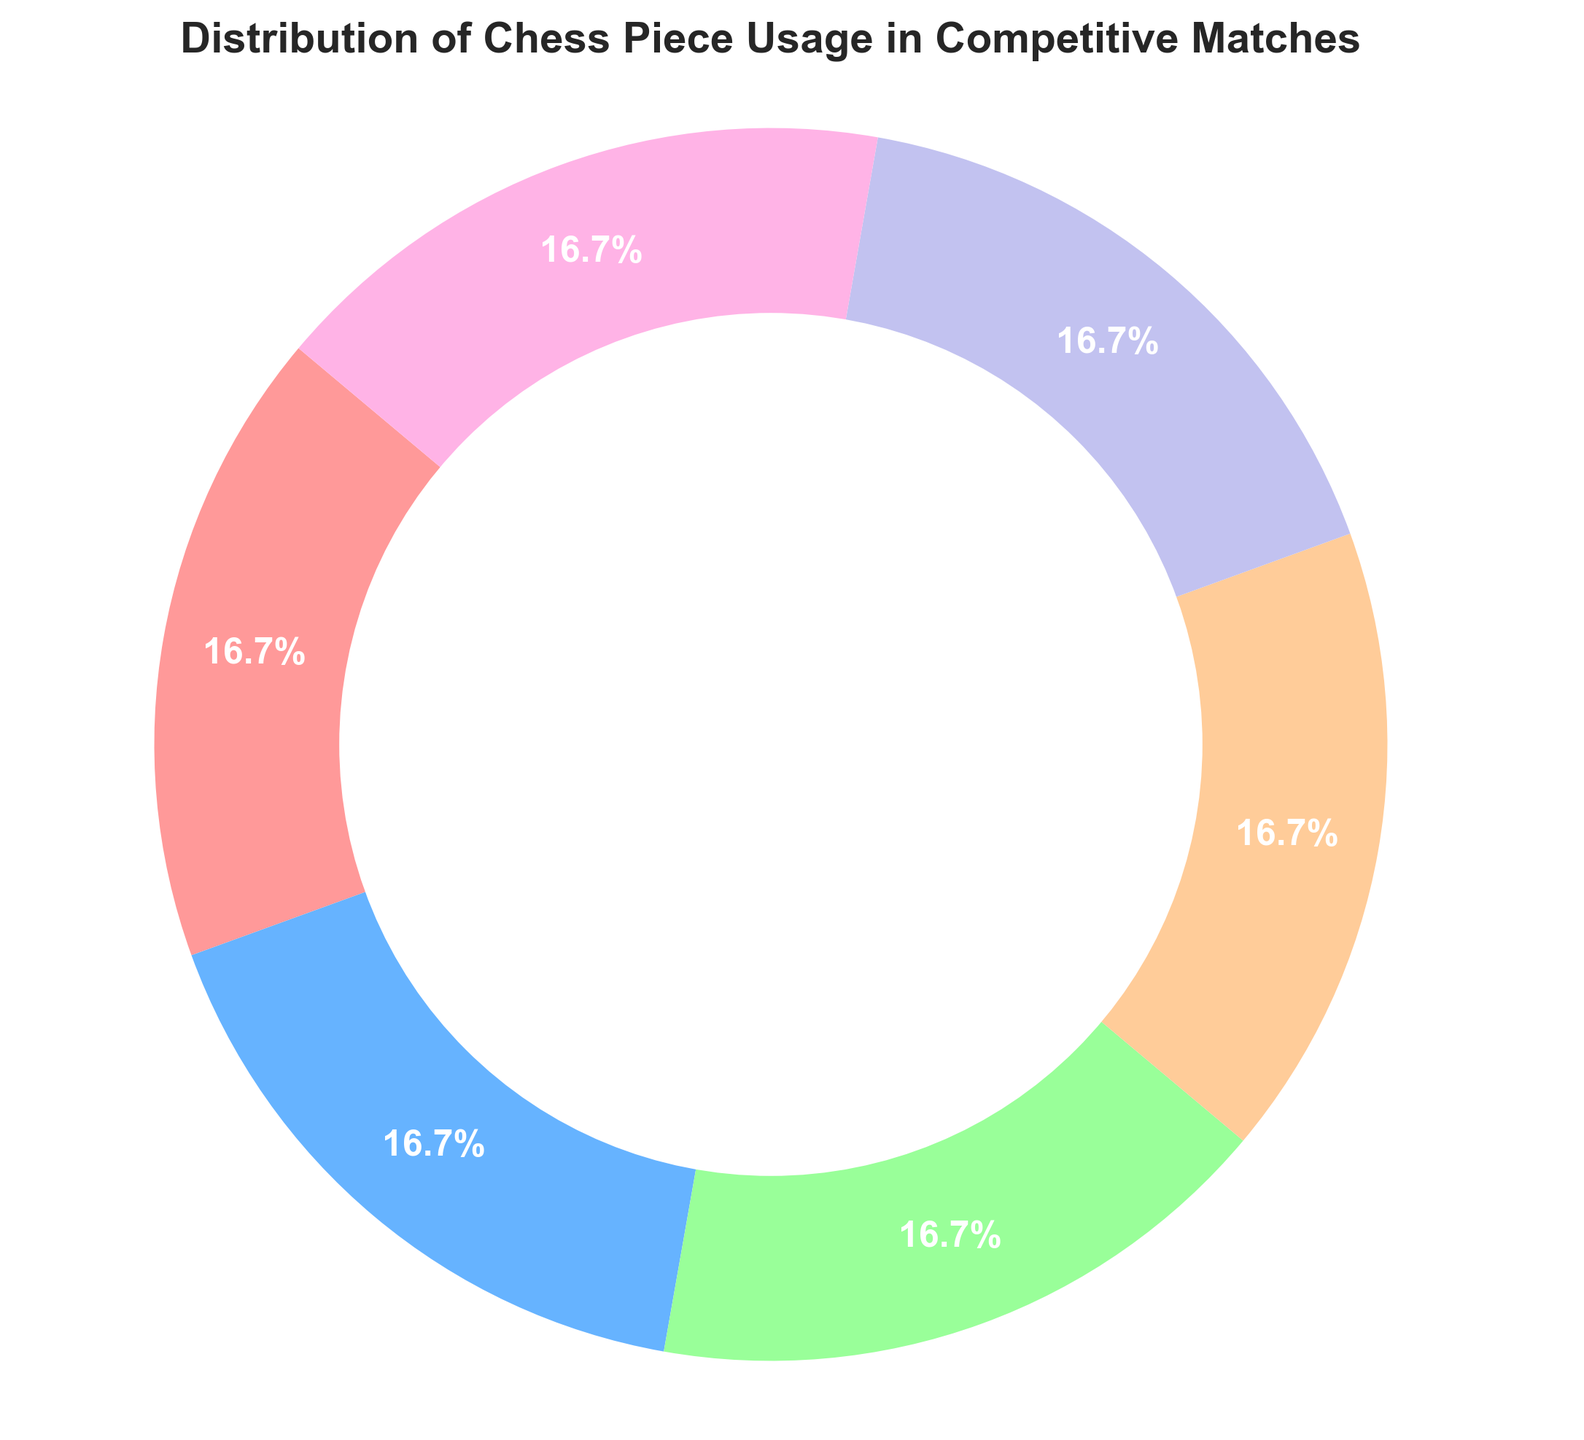What percentage of the total pie chart is occupied by the King and Queen combined? To find the combined percentage of the King and Queen, add their individual usage percentages: 16.67% + 16.67% = 33.34%.
Answer: 33.34% Which chess piece shares the same usage percentage as the Bishop? According to the pie chart, all pieces have the same usage percentage, which is 16.67%. Therefore, all pieces, including the Queen, Rook, Knight, and Pawn, share the same percentage as the Bishop.
Answer: Queen, Rook, Knight, Pawn Is there any chess piece that has a higher usage percentage than the Knight? The pie chart shows that all chess pieces have an equal usage percentage of 16.67%. Therefore, no piece has a higher usage percentage than the Knight.
Answer: No What is the difference in usage percentage between the Rook and the Pawn? Both the Rook and the Pawn have the same usage percentage of 16.67%. The difference between their usage percentages is 16.67% - 16.67% = 0%.
Answer: 0% Which segment of the pie chart is displayed in red? Based on the provided color scheme, the first color (#ff9999) represents red. Assuming the first segment in the chart corresponds to the King, the King is displayed in red.
Answer: King If we combine the usage percentages of the Rook, Knight, and Pawn, what is the resultant percentage? Sum the usage percentages of the Rook, Knight, and Pawn: 16.67% + 16.67% + 16.67% = 50.01%.
Answer: 50.01% Which piece comes just before the one displayed in green on the pie chart? Assuming the color sequence is followed and given green is usually in the middle, we check the sequence. The green piece is the third in the color list, so the piece just before it (in blue) is the Queen.
Answer: Queen If you were to remove the section representing Bishops, what percentage of the chart would remain? Removing Bishops' usage percentage from the total 100%, you get: 100% - 16.67% = 83.33%.
Answer: 83.33% Are there any pairs of pieces that have equal usage percentages? From the data provided, all pieces (King, Queen, Rook, Bishop, Knight, Pawn) have the same usage percentage of 16.67%. All possible pairs have equal usage percentages.
Answer: Yes Which piece has the smallest percentage usage in the pie chart? All pieces have the same usage percentage of 16.67%. Thus, no piece has a smallest percentage usage; they are all equal.
Answer: None 